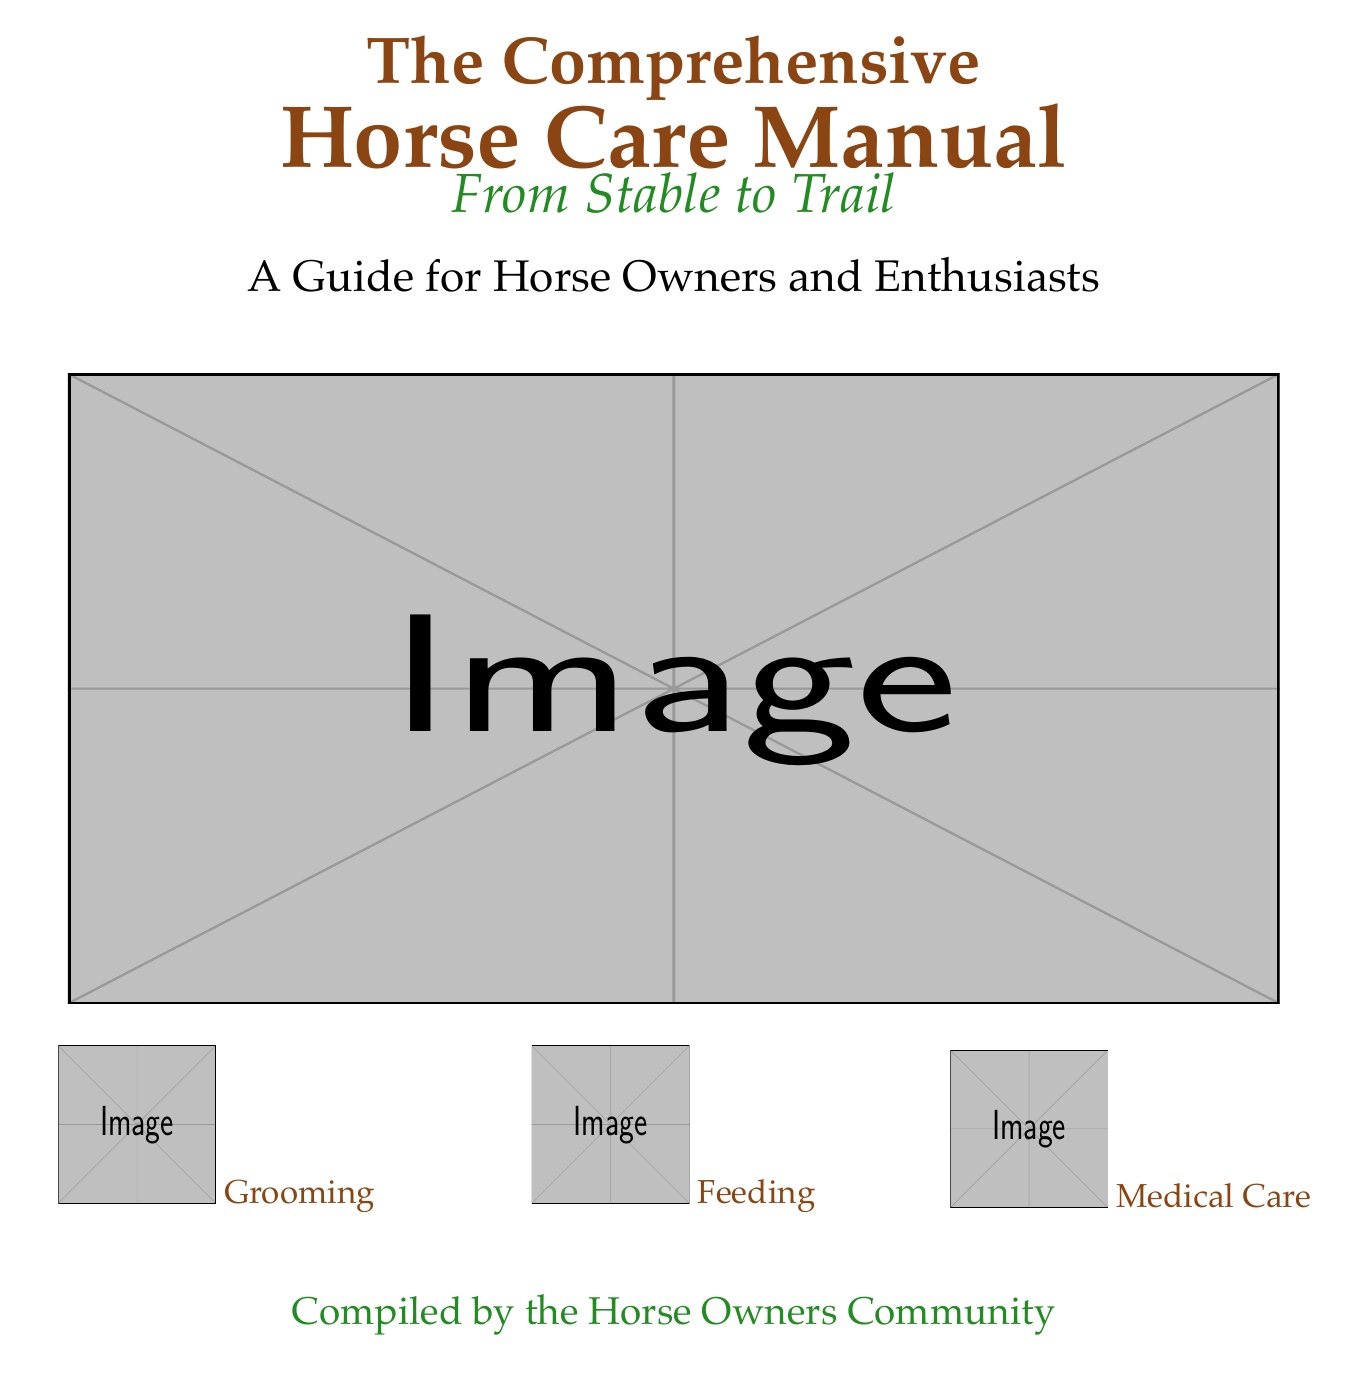What is the title of the book? The title is prominently displayed at the top of the document in large font.
Answer: The Comprehensive Horse Care Manual What is the subtitle of the book? The subtitle is located below the title and provides additional context about the content.
Answer: From Stable to Trail Who compiled the book? The author's name is found at the bottom of the document.
Answer: the Horse Owners Community What color represents grooming in the icons? The color for grooming is shown in the label under the corresponding icon on the cover.
Answer: rusticbrown What is the main focus of this manual? The focus of the manual is inferred from the title, which indicates it provides comprehensive care information.
Answer: Horse Care What type of care does the icon represent with a medical symbol? The medical care icon signifies a specific area of knowledge and responsibility for horse owners.
Answer: Medical Care How many icons are depicted on the cover? The icons are grouped together toward the bottom of the cover, which visually clarifies the main areas covered.
Answer: Three What is the main theme conveyed through the imagery on the cover? The imagery includes a stable and horses, which establishes a serene and caring environment associated with horse ownership.
Answer: Horse care What is the intended audience for this manual? The audience is specified in the description on the cover and indicates who the book is targeted towards.
Answer: Horse Owners and Enthusiasts 